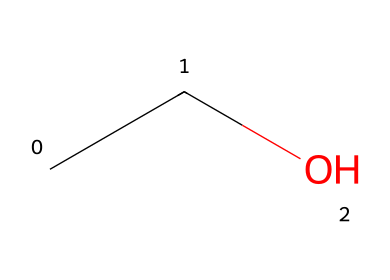What is the molecular formula of this chemical? The chemical structure shown in the SMILES representation (CCO) corresponds to ethanol, which contains two carbon atoms (C), six hydrogen atoms (H), and one oxygen atom (O). Thus, the molecular formula is C2H6O.
Answer: C2H6O How many carbon atoms are present in the molecule? The SMILES representation shows "CC" which indicates two carbon atoms are present in the chemical structure.
Answer: 2 What is the functional group present in ethanol? In the SMILES representation (CCO), the oxygen atom is bonded to an alkyl group (the carbons), indicating that the functional group present is a hydroxyl group (-OH).
Answer: hydroxyl What type of compound is represented by this chemical? Ethanol, as represented in the SMILES notation (CCO), is classified as an alcohol due to the presence of the hydroxyl functional group, which is characteristic of alcohols.
Answer: alcohol Does this chemical have the potential for toxicity? Ethanol is known to have toxic effects when consumed in high quantities, affecting the central nervous system and leading to impairment. Thus, yes, it can be toxic under certain conditions.
Answer: yes What is the total number of hydrogen atoms in this molecule? The SMILES notation shows "CC" which represents the two carbon atoms contributing a total of 5 hydrogens, and the hydroxyl group contributes one hydrogen atom, amounting to a total of 6 hydrogen atoms.
Answer: 6 